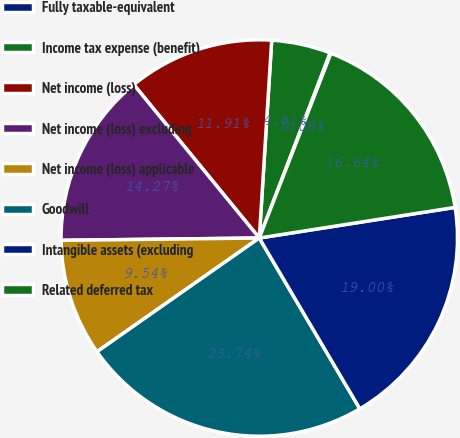Convert chart to OTSL. <chart><loc_0><loc_0><loc_500><loc_500><pie_chart><fcel>Fully taxable-equivalent<fcel>Income tax expense (benefit)<fcel>Net income (loss)<fcel>Net income (loss) excluding<fcel>Net income (loss) applicable<fcel>Goodwill<fcel>Intangible assets (excluding<fcel>Related deferred tax<nl><fcel>0.08%<fcel>4.81%<fcel>11.91%<fcel>14.27%<fcel>9.54%<fcel>23.74%<fcel>19.0%<fcel>16.64%<nl></chart> 